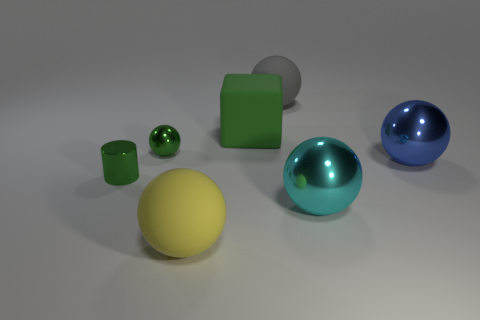What material is the blue sphere that is the same size as the green cube?
Your answer should be compact. Metal. Do the tiny metal object that is behind the small shiny cylinder and the big cube that is on the right side of the tiny green metal cylinder have the same color?
Keep it short and to the point. Yes. Is there anything else of the same color as the tiny cylinder?
Give a very brief answer. Yes. Is there any other thing that has the same shape as the green matte thing?
Make the answer very short. No. What color is the large object that is both left of the big gray rubber object and in front of the green block?
Offer a very short reply. Yellow. Are there more cyan metal spheres than spheres?
Ensure brevity in your answer.  No. What number of objects are either big red matte cylinders or small shiny things that are behind the big blue metallic thing?
Ensure brevity in your answer.  1. Does the green matte thing have the same size as the green metal cylinder?
Offer a very short reply. No. There is a gray thing; are there any matte spheres to the left of it?
Offer a very short reply. Yes. There is a metallic ball that is both behind the big cyan object and on the right side of the tiny sphere; what is its size?
Give a very brief answer. Large. 